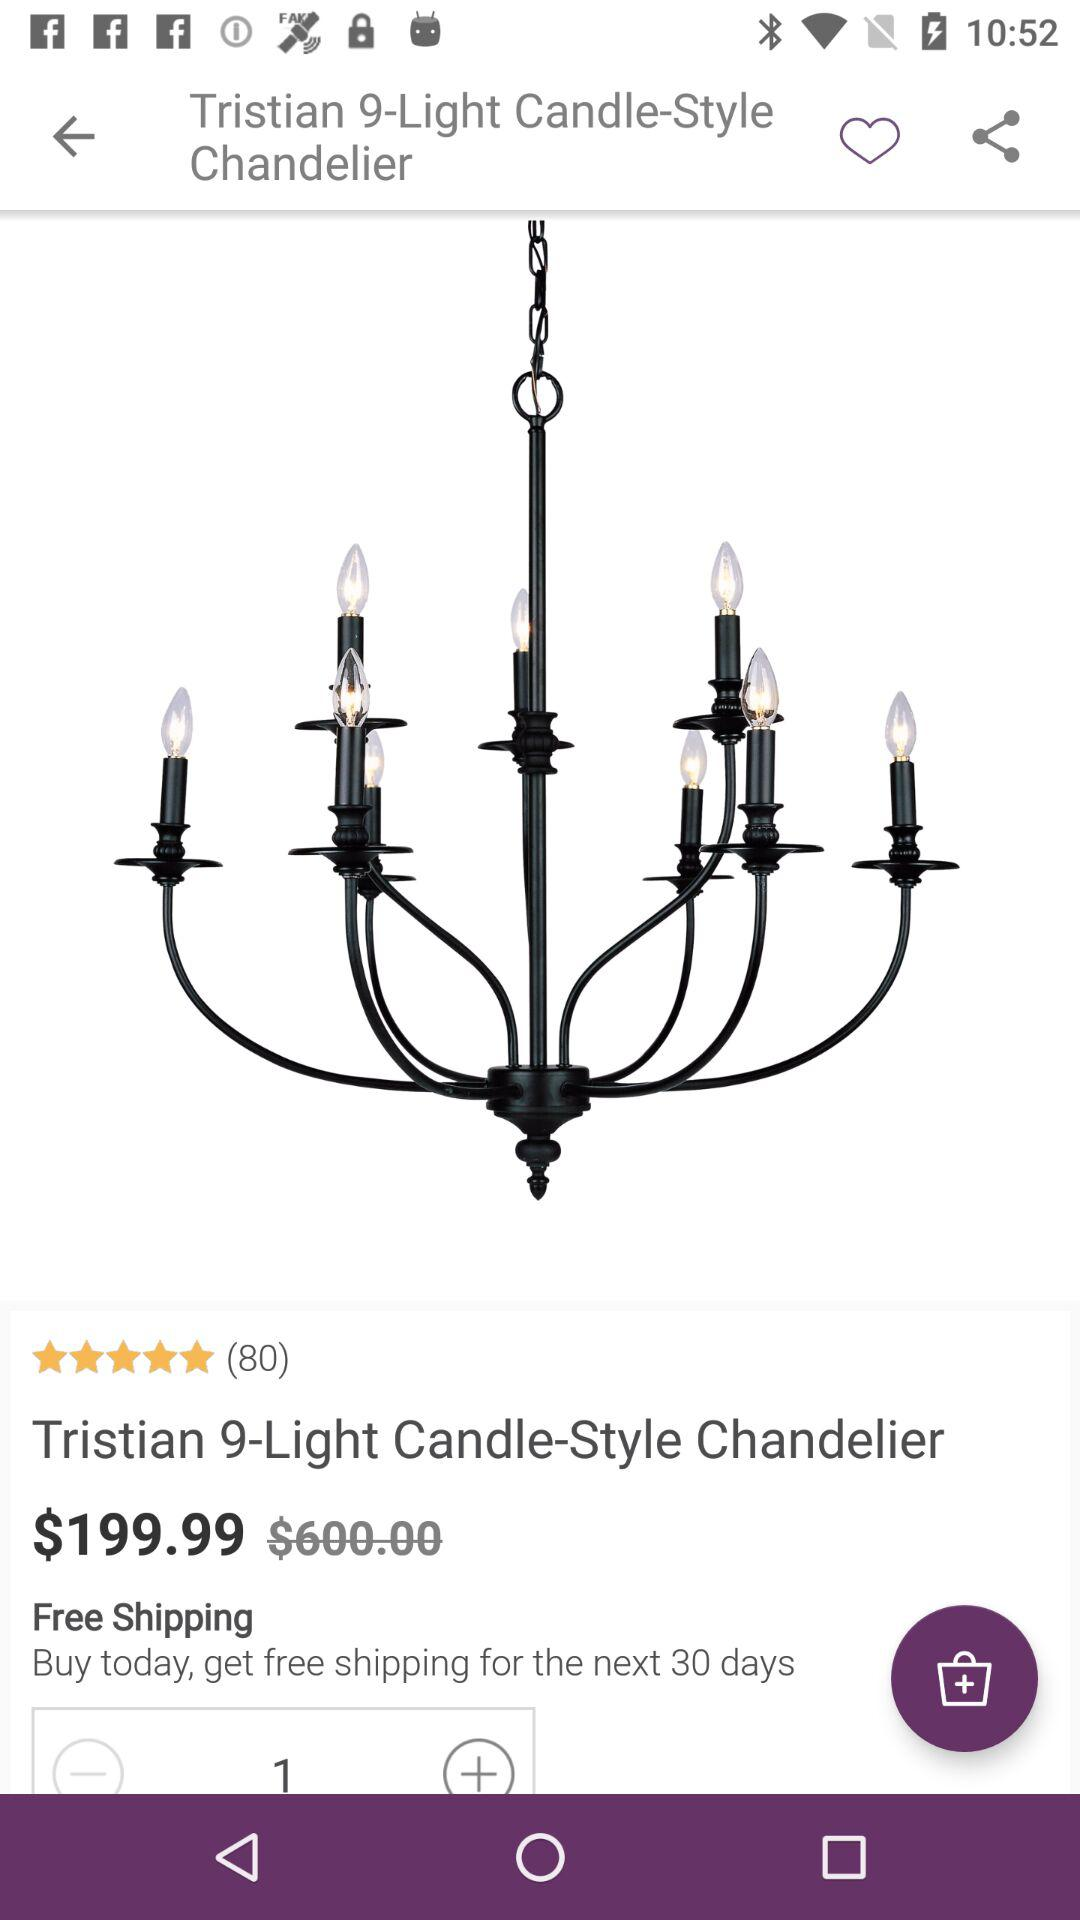How much is the product if I add 50 to the price?
Answer the question using a single word or phrase. $249.99 